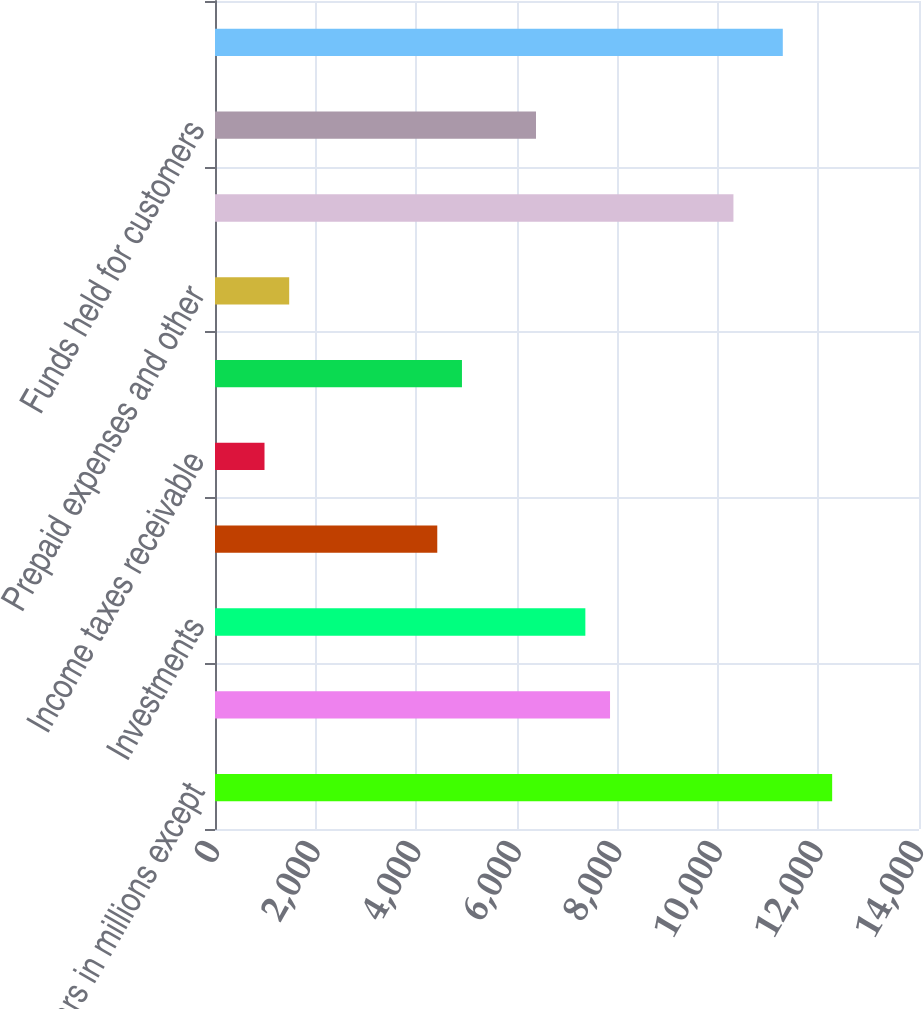Convert chart. <chart><loc_0><loc_0><loc_500><loc_500><bar_chart><fcel>(Dollars in millions except<fcel>Cash and cash equivalents<fcel>Investments<fcel>Accounts receivable net of<fcel>Income taxes receivable<fcel>Deferred income taxes<fcel>Prepaid expenses and other<fcel>Current assets before funds<fcel>Funds held for customers<fcel>Total current assets<nl><fcel>12273<fcel>7855.8<fcel>7365<fcel>4420.2<fcel>984.6<fcel>4911<fcel>1475.4<fcel>10309.8<fcel>6383.4<fcel>11291.4<nl></chart> 